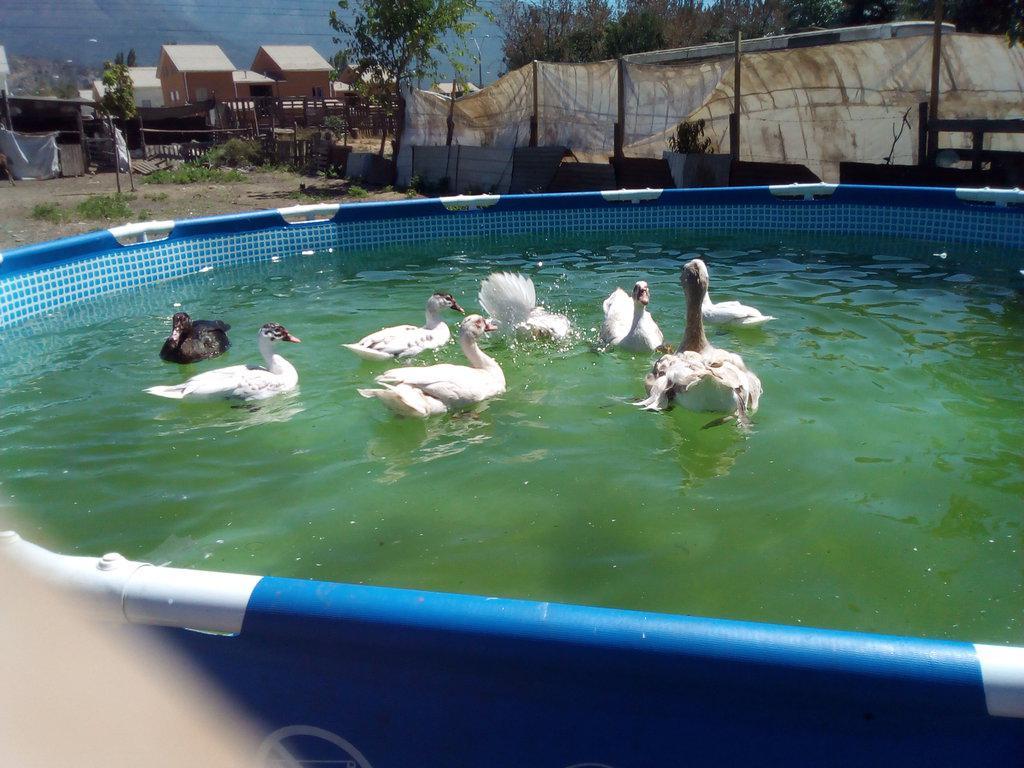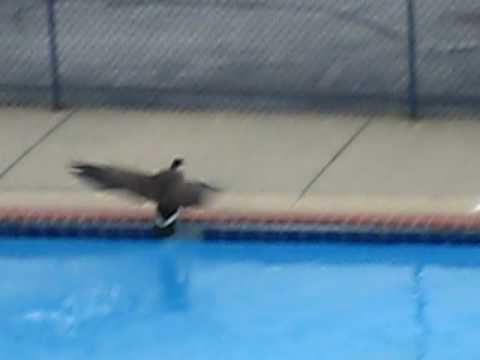The first image is the image on the left, the second image is the image on the right. Evaluate the accuracy of this statement regarding the images: "Some of the birds are darker than the others.". Is it true? Answer yes or no. Yes. The first image is the image on the left, the second image is the image on the right. For the images displayed, is the sentence "There are more than three ducks in water." factually correct? Answer yes or no. Yes. 